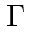Convert formula to latex. <formula><loc_0><loc_0><loc_500><loc_500>\Gamma</formula> 